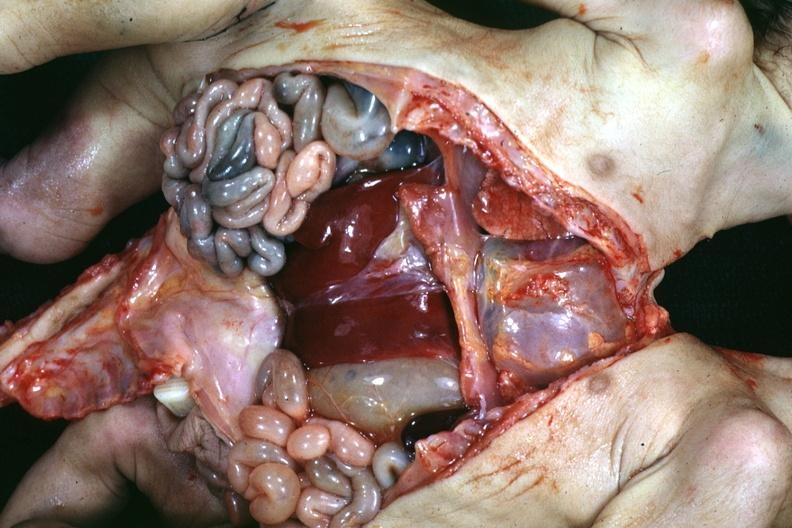s siamese twins present?
Answer the question using a single word or phrase. Yes 